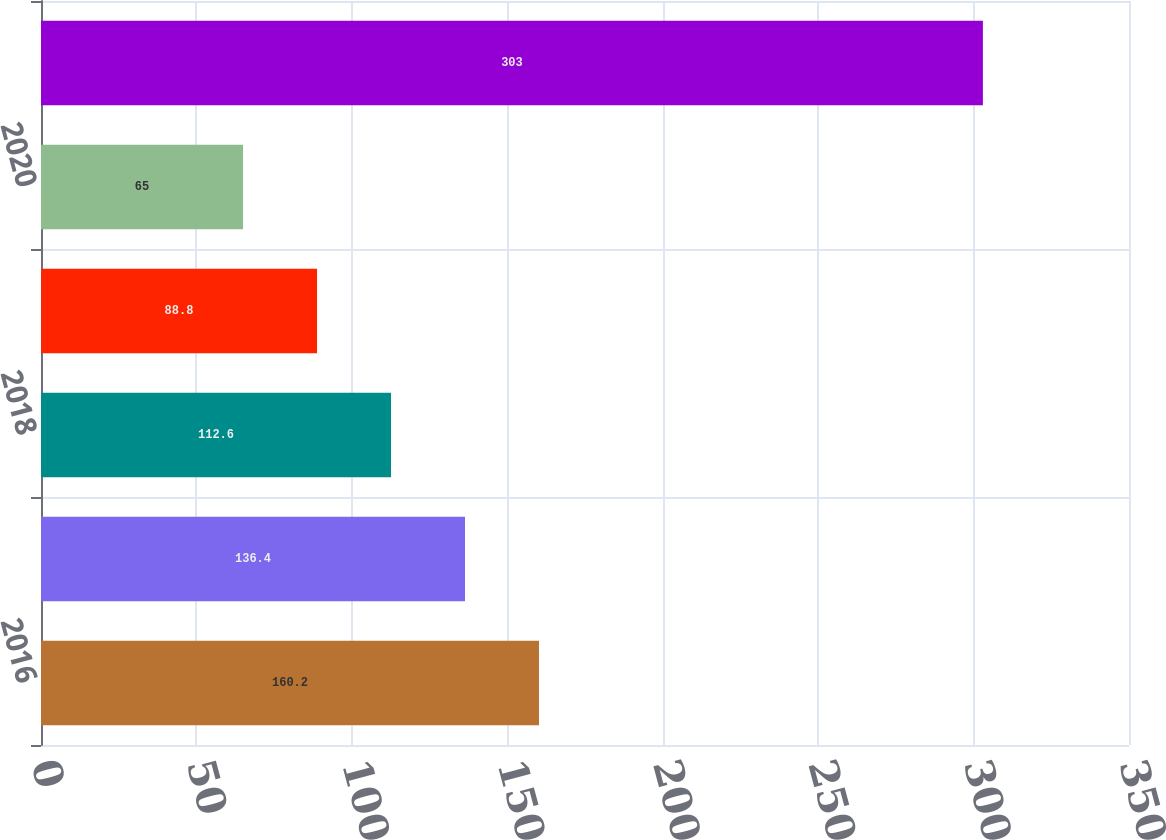Convert chart. <chart><loc_0><loc_0><loc_500><loc_500><bar_chart><fcel>2016<fcel>2017<fcel>2018<fcel>2019<fcel>2020<fcel>2021-2025<nl><fcel>160.2<fcel>136.4<fcel>112.6<fcel>88.8<fcel>65<fcel>303<nl></chart> 